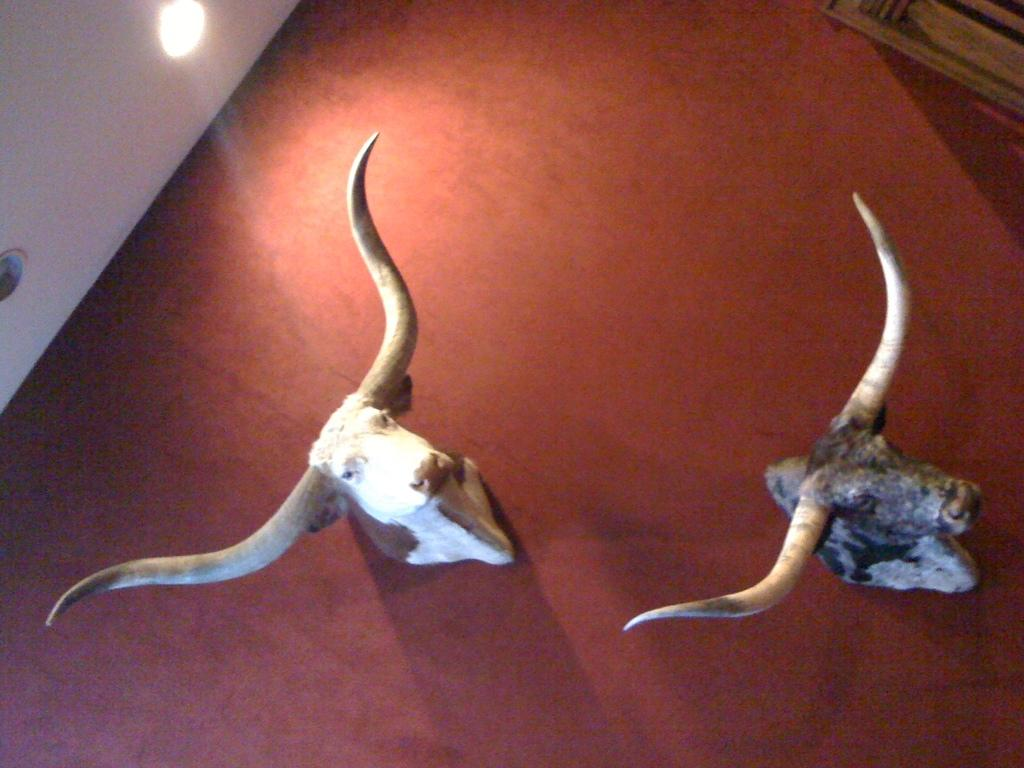What is the main subject of the image? The main subject of the image is two animal heads. What color is the background of the image? The background of the image is red. Can you describe any other elements in the image? There is a light on the ceiling in the top left corner of the image. How many crates are stacked next to the animal heads in the image? There are no crates present in the image. What is the boy doing in the image? There is no boy present in the image. Is there a yak in the image? There is no yak present in the image. 